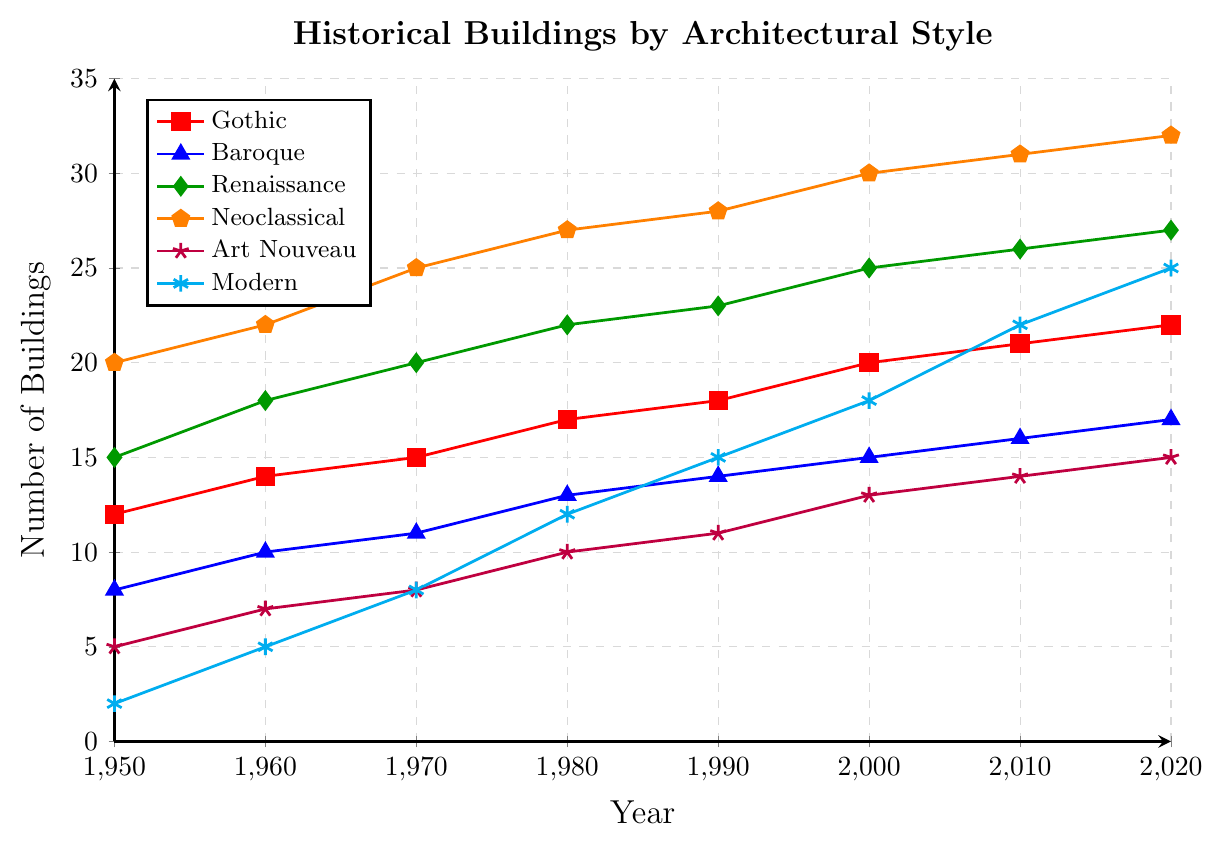How many Gothic buildings were registered in 1980 compared to 1950? The number of Gothic buildings in 1980 is 17 according to the chart, while in 1950 it is 12. Therefore, 17 Gothic buildings were registered in 1980 compared to 12 in 1950.
Answer: 17 vs. 12 Which architectural style saw the greatest increase in registered buildings from 1950 to 2020? By observing the end and start values for each style, Modern buildings increased from 2 to 25, which is an increase of 23. This is the largest among all styles.
Answer: Modern In 2020, which architectural style has more registered buildings: Art Nouveau or Baroque? By looking at the 2020 data points, Art Nouveau has 15 buildings, and Baroque has 17 buildings. So, Baroque has more registered buildings in 2020.
Answer: Baroque What is the total number of registered Renaissance and Gothic buildings in the year 2000? Renaissance buildings are 25 and Gothic buildings are 20 in 2000. Summing these gives 25 + 20 = 45 registered Renaissance and Gothic buildings.
Answer: 45 Compare the growth trend of Neoclassical and Baroque buildings from 1950 to 2020. Which one shows a steeper increase? Neoclassical buildings grew from 20 to 32, an increase of 12, while Baroque buildings grew from 8 to 17, an increase of 9. Therefore, Neoclassical shows a steeper increase.
Answer: Neoclassical Identify the style that had the least number of buildings in 1970. According to the figure, Modern had 8 buildings in 1970, which is the smallest number among all styles listed.
Answer: Modern Calculate the average number of registered Modern buildings every decade from 1950 to 2020. Summing the Modern buildings (2, 5, 8, 12, 15, 18, 22, 25) equals 107. There are 8 decades, so the average is 107 / 8 = 13.375 (rounded to 3 decimal places).
Answer: 13.375 Which architectural style had the largest number of buildings in the year 1960? From the data, Neoclassical had 22 buildings in 1960, which is the highest number for that year compared to the other styles.
Answer: Neoclassical 